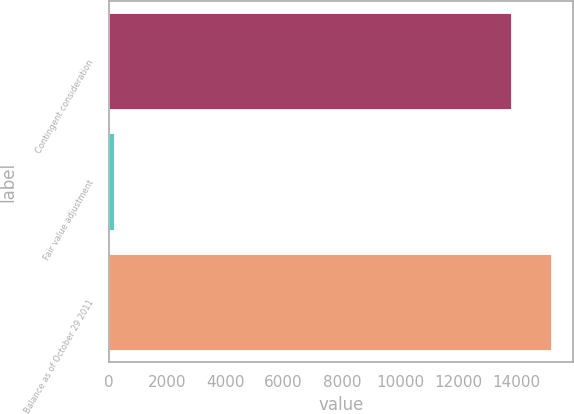Convert chart. <chart><loc_0><loc_0><loc_500><loc_500><bar_chart><fcel>Contingent consideration<fcel>Fair value adjustment<fcel>Balance as of October 29 2011<nl><fcel>13790<fcel>183<fcel>15169<nl></chart> 